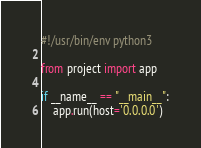<code> <loc_0><loc_0><loc_500><loc_500><_Python_>#!/usr/bin/env python3

from project import app

if __name__ == "__main__":
    app.run(host='0.0.0.0')</code> 